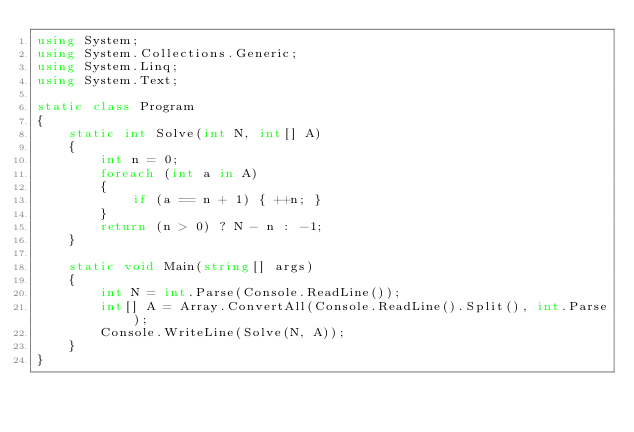Convert code to text. <code><loc_0><loc_0><loc_500><loc_500><_C#_>using System;
using System.Collections.Generic;
using System.Linq;
using System.Text;

static class Program
{
    static int Solve(int N, int[] A)
    {
        int n = 0;
        foreach (int a in A)
        {
            if (a == n + 1) { ++n; }
        }
        return (n > 0) ? N - n : -1;
    }

    static void Main(string[] args)
    {
        int N = int.Parse(Console.ReadLine());
        int[] A = Array.ConvertAll(Console.ReadLine().Split(), int.Parse);
        Console.WriteLine(Solve(N, A));
    }
}
</code> 